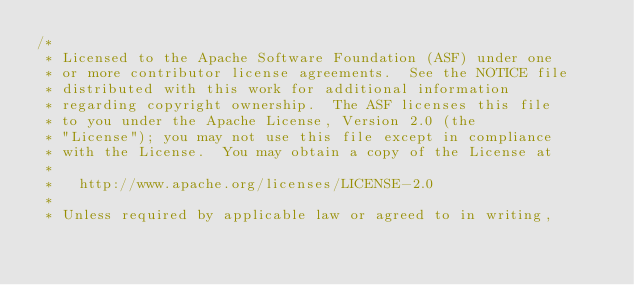<code> <loc_0><loc_0><loc_500><loc_500><_Java_>/*
 * Licensed to the Apache Software Foundation (ASF) under one
 * or more contributor license agreements.  See the NOTICE file
 * distributed with this work for additional information
 * regarding copyright ownership.  The ASF licenses this file
 * to you under the Apache License, Version 2.0 (the
 * "License"); you may not use this file except in compliance
 * with the License.  You may obtain a copy of the License at
 *
 *   http://www.apache.org/licenses/LICENSE-2.0
 *
 * Unless required by applicable law or agreed to in writing,</code> 